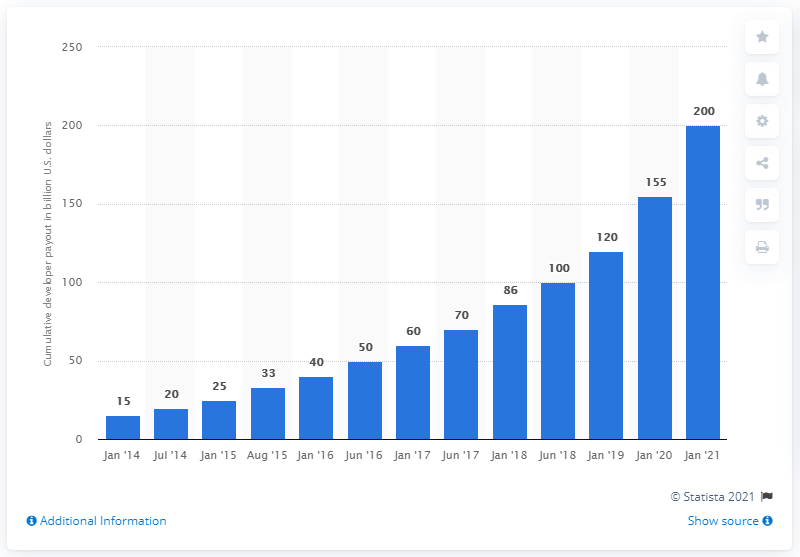Mention a couple of crucial points in this snapshot. Last year, Apple paid out a total of 155 to developers. As of January 2021, Apple had paid a total of $200 billion to developers selling goods and services through the App Store. 